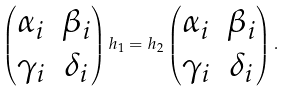Convert formula to latex. <formula><loc_0><loc_0><loc_500><loc_500>\begin{pmatrix} \alpha _ { i } & \beta _ { i } \\ \gamma _ { i } & \delta _ { i } \end{pmatrix} h _ { 1 } = h _ { 2 } \begin{pmatrix} \alpha _ { i } & \beta _ { i } \\ \gamma _ { i } & \delta _ { i } \end{pmatrix} .</formula> 